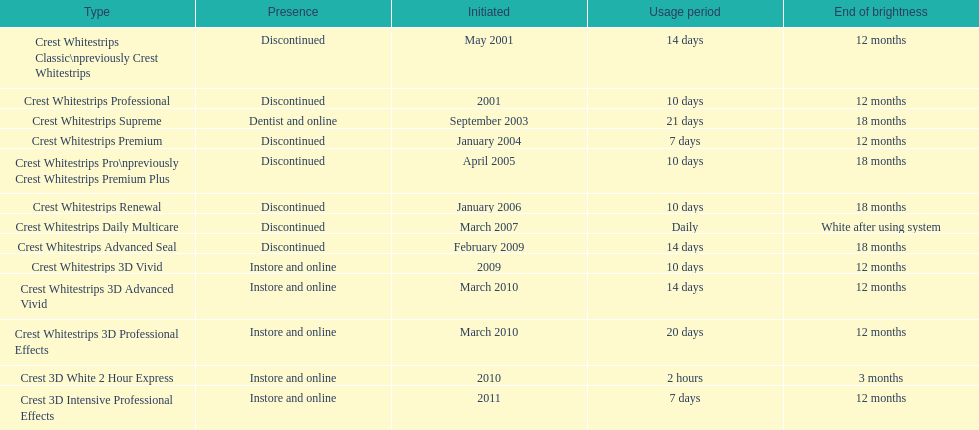Which discontinued item was presented in the same year as crest whitestrips 3d vivid? Crest Whitestrips Advanced Seal. 